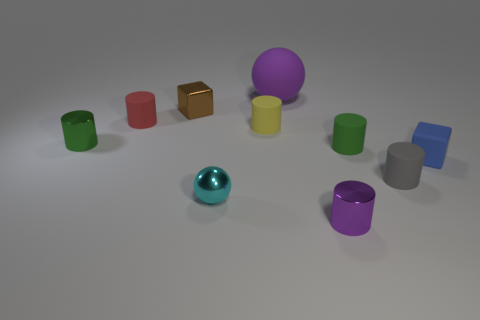Subtract all red cylinders. How many cylinders are left? 5 Subtract all gray cylinders. How many cylinders are left? 5 Subtract all cyan cylinders. Subtract all cyan cubes. How many cylinders are left? 6 Subtract all cylinders. How many objects are left? 4 Subtract all tiny yellow objects. Subtract all small cyan metal objects. How many objects are left? 8 Add 9 green rubber objects. How many green rubber objects are left? 10 Add 3 big rubber things. How many big rubber things exist? 4 Subtract 0 cyan cylinders. How many objects are left? 10 